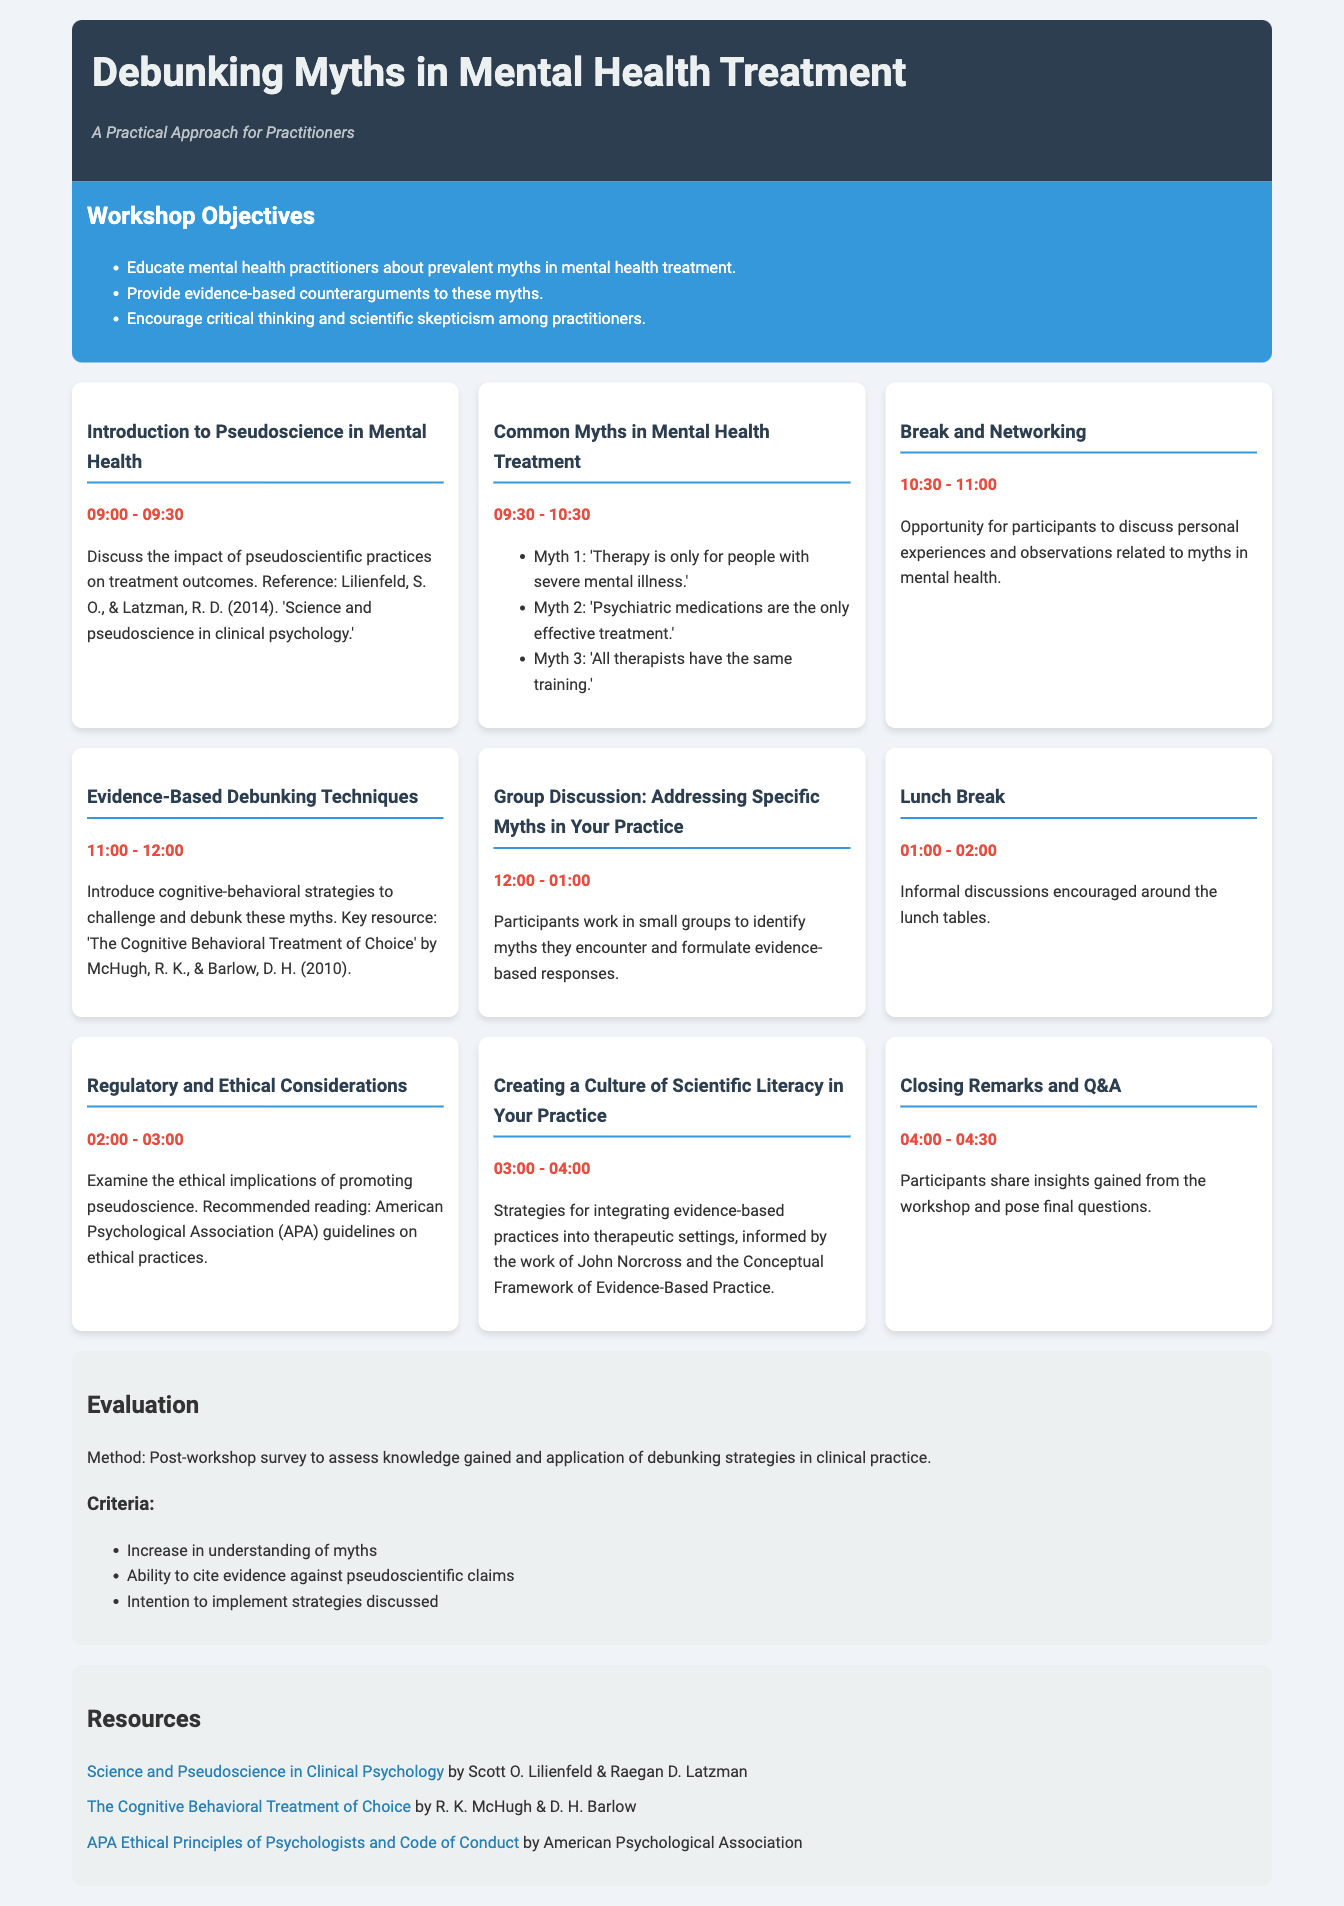What are the workshop objectives? The workshop objectives are listed in a section, highlighting the aims of educating practitioners about myths, providing counterarguments, and encouraging critical thinking.
Answer: Educate mental health practitioners about prevalent myths in mental health treatment, provide evidence-based counterarguments to these myths, encourage critical thinking and scientific skepticism among practitioners What time does the "Common Myths in Mental Health Treatment" session start? The time for each session is specified under the session titles in the agenda; this one starts at 09:30.
Answer: 09:30 What is one of the strategies mentioned for debunking myths? The document includes a section that discusses introducing cognitive-behavioral strategies to challenge and debunk myths.
Answer: Cognitive-behavioral strategies What is the purpose of the lunch break? The document describes this break as an opportunity for informal discussions among participants, reflecting on the workshop's content.
Answer: Informal discussions encouraged around the lunch tables Who are the authors of the recommended reading for ethical considerations? The document cites the American Psychological Association as the source for ethical guidelines.
Answer: American Psychological Association What is the method of evaluation for the workshop? The evaluation method is clearly stated in the document as being a post-workshop survey assessing knowledge and application of strategies.
Answer: Post-workshop survey What session follows "Group Discussion: Addressing Specific Myths in Your Practice"? The agenda lists the next session that occurs after the group discussion, which is the lunch break.
Answer: Lunch Break How long is the "Closing Remarks and Q&A" session? The duration of each session is mentioned in the agenda, and this session lasts for 30 minutes.
Answer: 30 minutes 